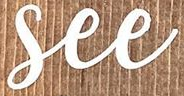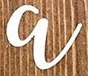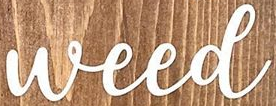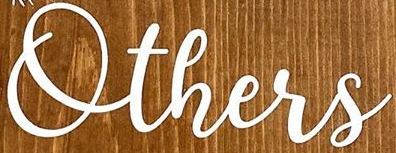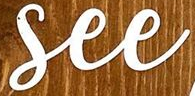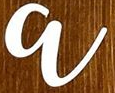What text appears in these images from left to right, separated by a semicolon? See; a; Weed; Others; See; a 